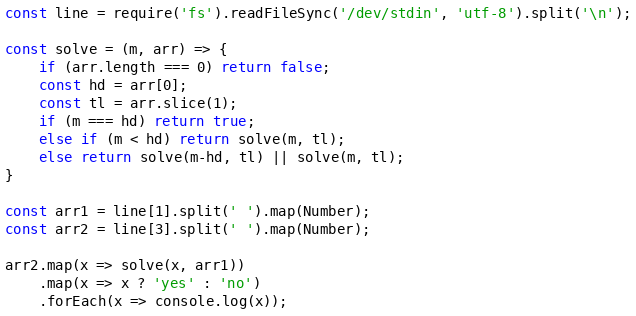<code> <loc_0><loc_0><loc_500><loc_500><_JavaScript_>const line = require('fs').readFileSync('/dev/stdin', 'utf-8').split('\n');

const solve = (m, arr) => {
    if (arr.length === 0) return false;
    const hd = arr[0];
    const tl = arr.slice(1);
    if (m === hd) return true;
    else if (m < hd) return solve(m, tl);
    else return solve(m-hd, tl) || solve(m, tl);
}

const arr1 = line[1].split(' ').map(Number);
const arr2 = line[3].split(' ').map(Number);

arr2.map(x => solve(x, arr1))
    .map(x => x ? 'yes' : 'no')
    .forEach(x => console.log(x));

</code> 